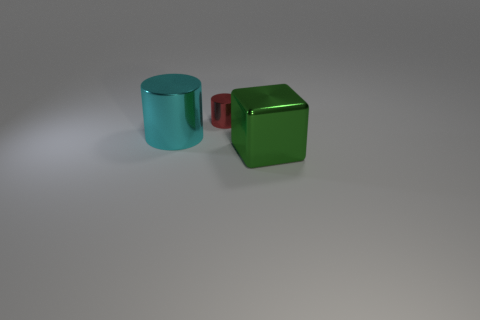Add 3 large cubes. How many objects exist? 6 Subtract all blocks. How many objects are left? 2 Subtract all large metal spheres. Subtract all large cyan shiny cylinders. How many objects are left? 2 Add 3 green blocks. How many green blocks are left? 4 Add 1 cyan cylinders. How many cyan cylinders exist? 2 Subtract 0 yellow cubes. How many objects are left? 3 